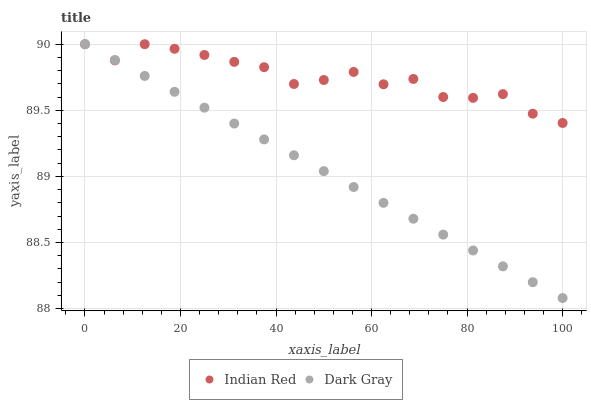Does Dark Gray have the minimum area under the curve?
Answer yes or no. Yes. Does Indian Red have the maximum area under the curve?
Answer yes or no. Yes. Does Indian Red have the minimum area under the curve?
Answer yes or no. No. Is Dark Gray the smoothest?
Answer yes or no. Yes. Is Indian Red the roughest?
Answer yes or no. Yes. Is Indian Red the smoothest?
Answer yes or no. No. Does Dark Gray have the lowest value?
Answer yes or no. Yes. Does Indian Red have the lowest value?
Answer yes or no. No. Does Indian Red have the highest value?
Answer yes or no. Yes. Does Indian Red intersect Dark Gray?
Answer yes or no. Yes. Is Indian Red less than Dark Gray?
Answer yes or no. No. Is Indian Red greater than Dark Gray?
Answer yes or no. No. 